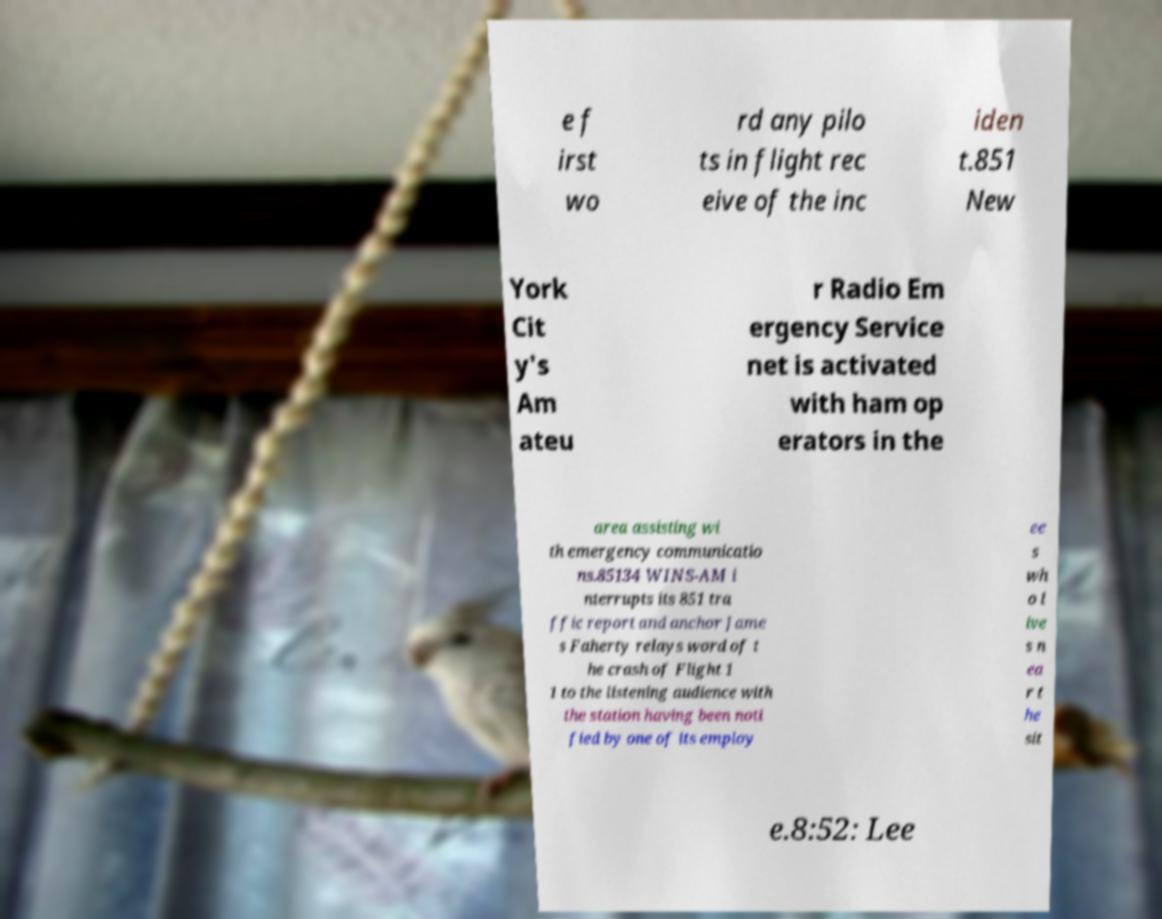Could you assist in decoding the text presented in this image and type it out clearly? e f irst wo rd any pilo ts in flight rec eive of the inc iden t.851 New York Cit y's Am ateu r Radio Em ergency Service net is activated with ham op erators in the area assisting wi th emergency communicatio ns.85134 WINS-AM i nterrupts its 851 tra ffic report and anchor Jame s Faherty relays word of t he crash of Flight 1 1 to the listening audience with the station having been noti fied by one of its employ ee s wh o l ive s n ea r t he sit e.8:52: Lee 